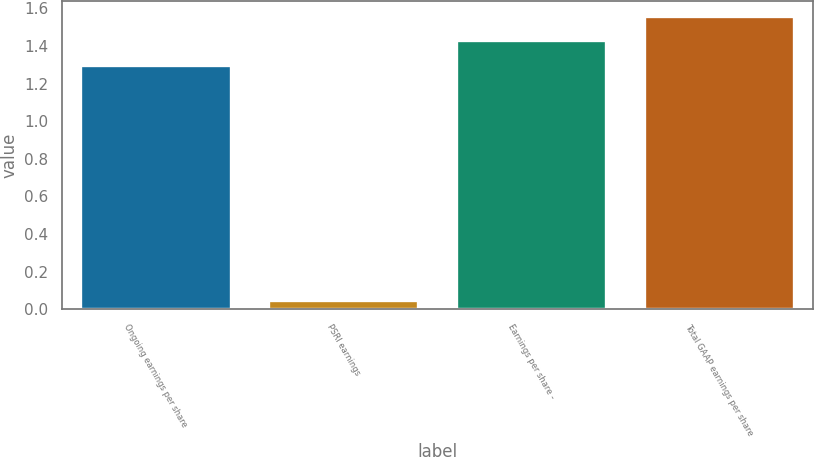<chart> <loc_0><loc_0><loc_500><loc_500><bar_chart><fcel>Ongoing earnings per share<fcel>PSRI earnings<fcel>Earnings per share -<fcel>Total GAAP earnings per share<nl><fcel>1.3<fcel>0.05<fcel>1.43<fcel>1.56<nl></chart> 